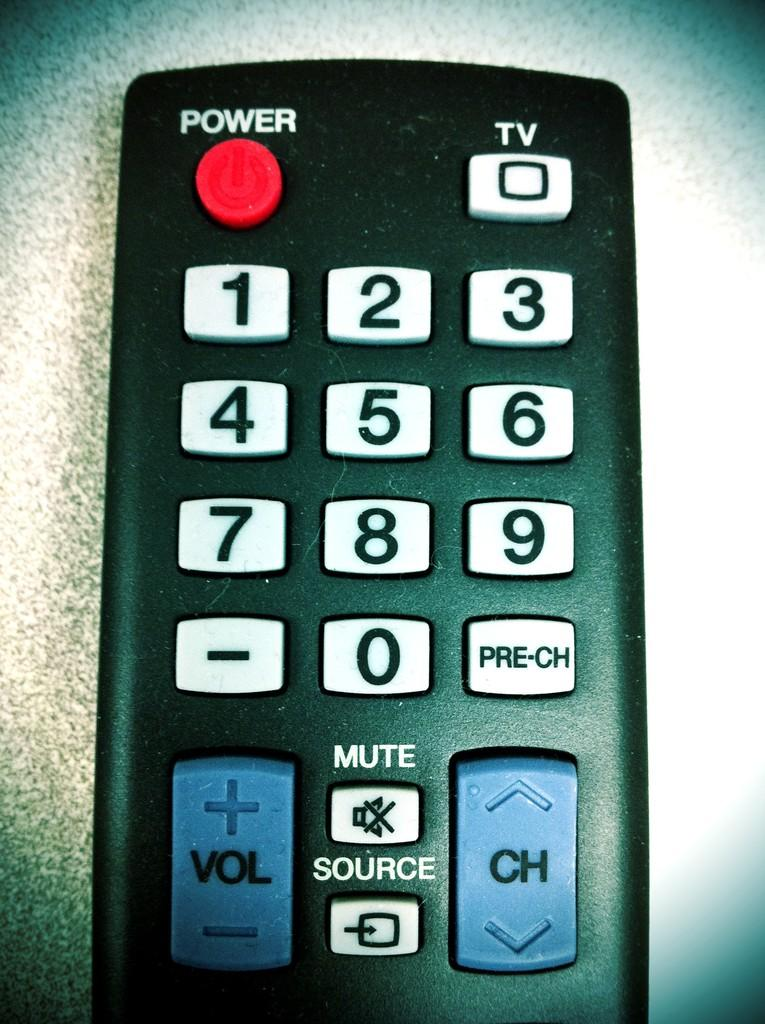<image>
Summarize the visual content of the image. A remote is laid on a hard surface and has a power button, TV button, numbers 0-9, and Volume, Channel, Mute, and Source buttons. 